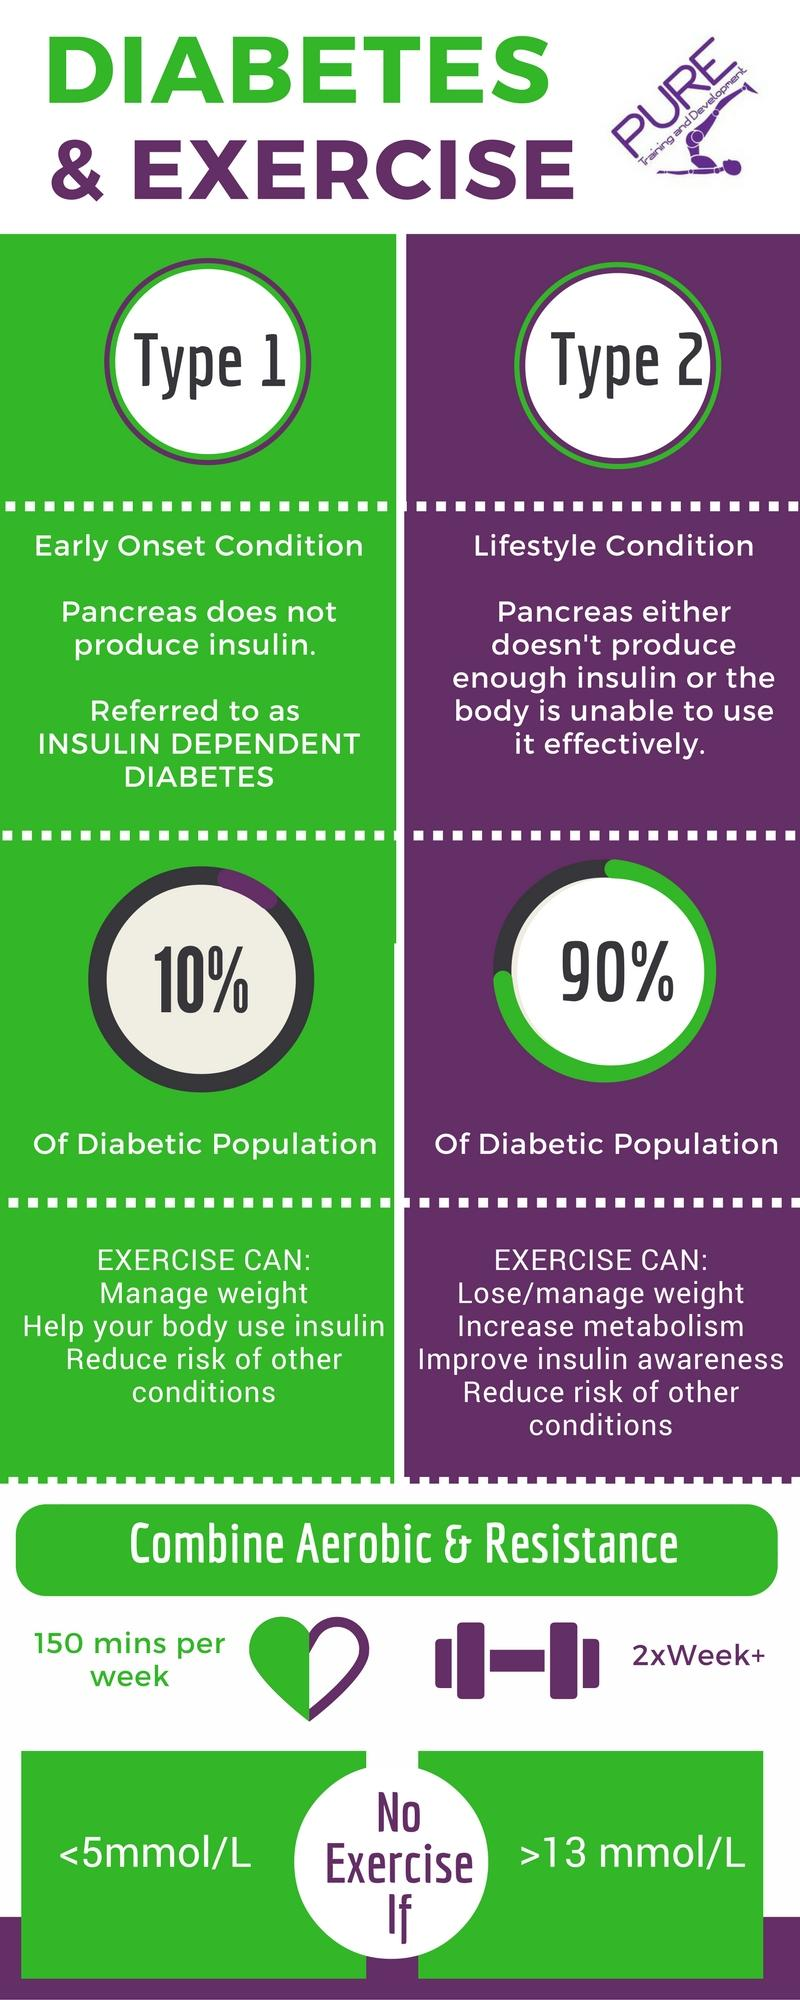Draw attention to some important aspects in this diagram. The main contributing factor for Type 2 diabetes is lifestyle. The article discusses various types of diabetes, including Type 1 and Type 2 diabetes. It is possible to control diabetes by participating in aerobic and resistance exercises. The pancreas is the organ associated with insulin. According to studies, exercising can guarantee a reduction in the risk of developing other conditions for 100% of the diabetic population. 